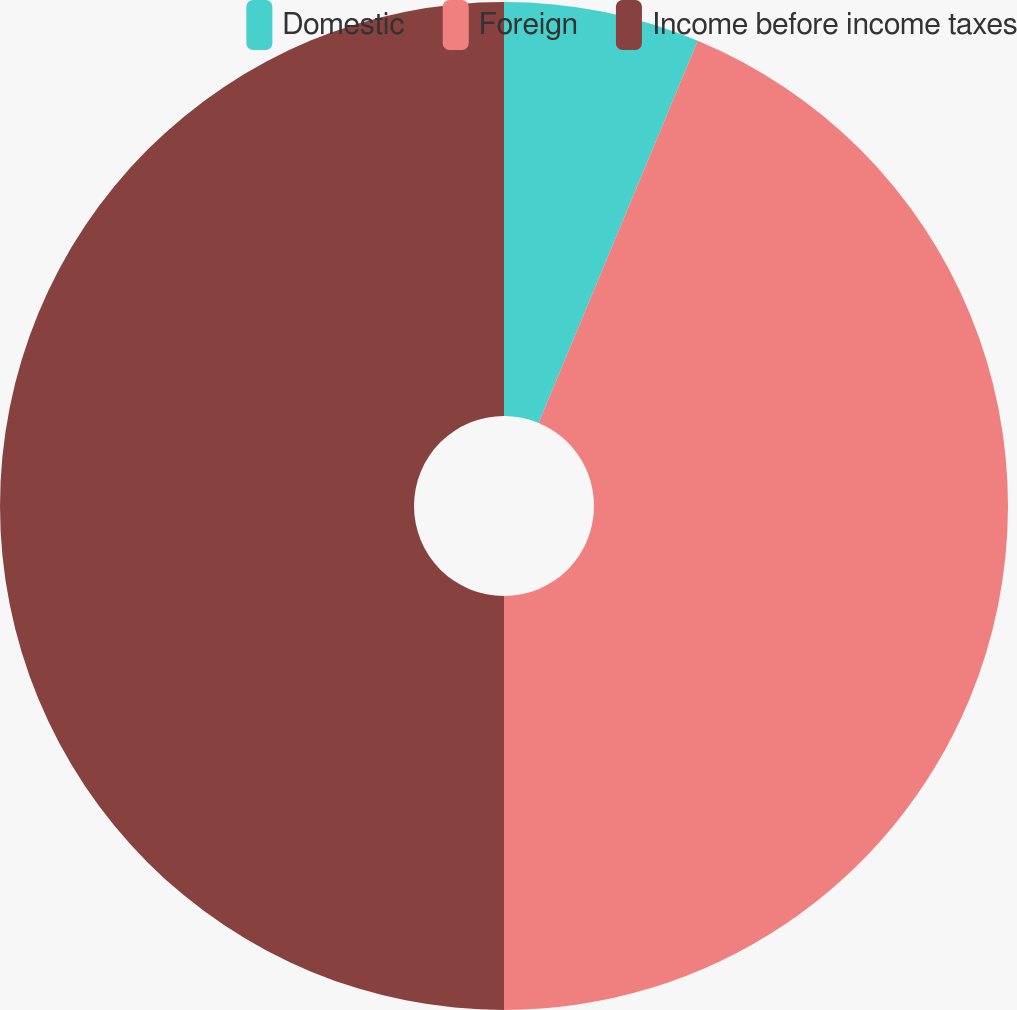Convert chart. <chart><loc_0><loc_0><loc_500><loc_500><pie_chart><fcel>Domestic<fcel>Foreign<fcel>Income before income taxes<nl><fcel>6.28%<fcel>43.72%<fcel>50.0%<nl></chart> 